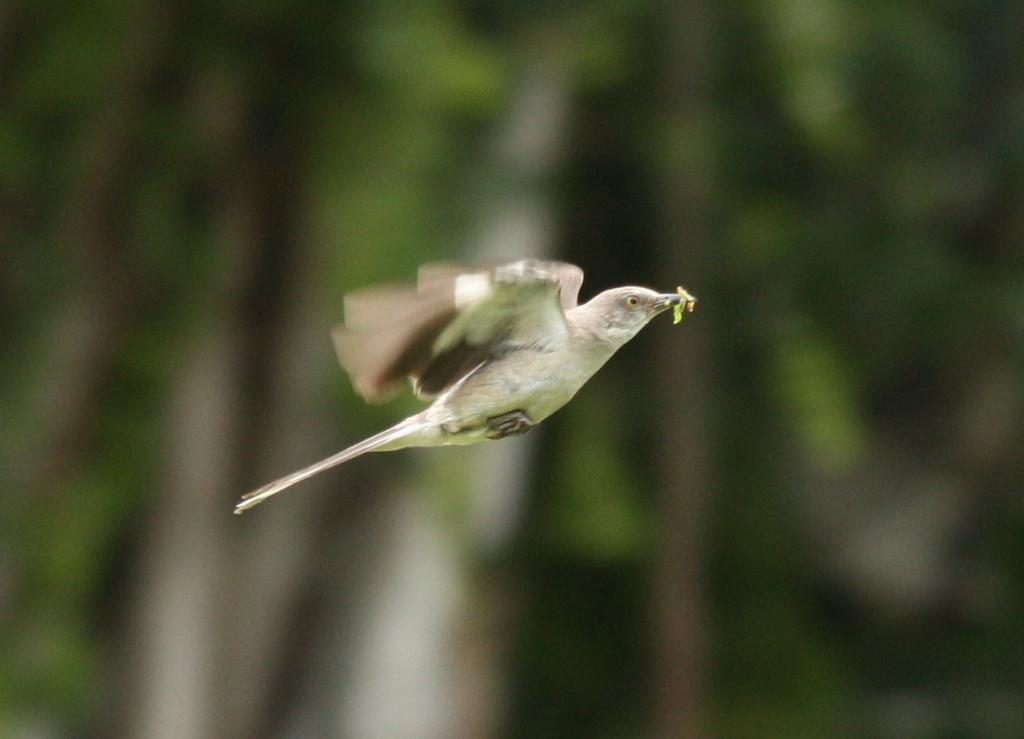What is the main subject of the image? There is a bird flying in the air. Can you describe the bird's activity in the image? The bird is flying in the air. What can be observed about the background of the image? The background of the image is blurry. How many squares can be seen in the image? There are no squares present in the image. Is the bird running in the image? The bird is not running in the image; it is flying. 